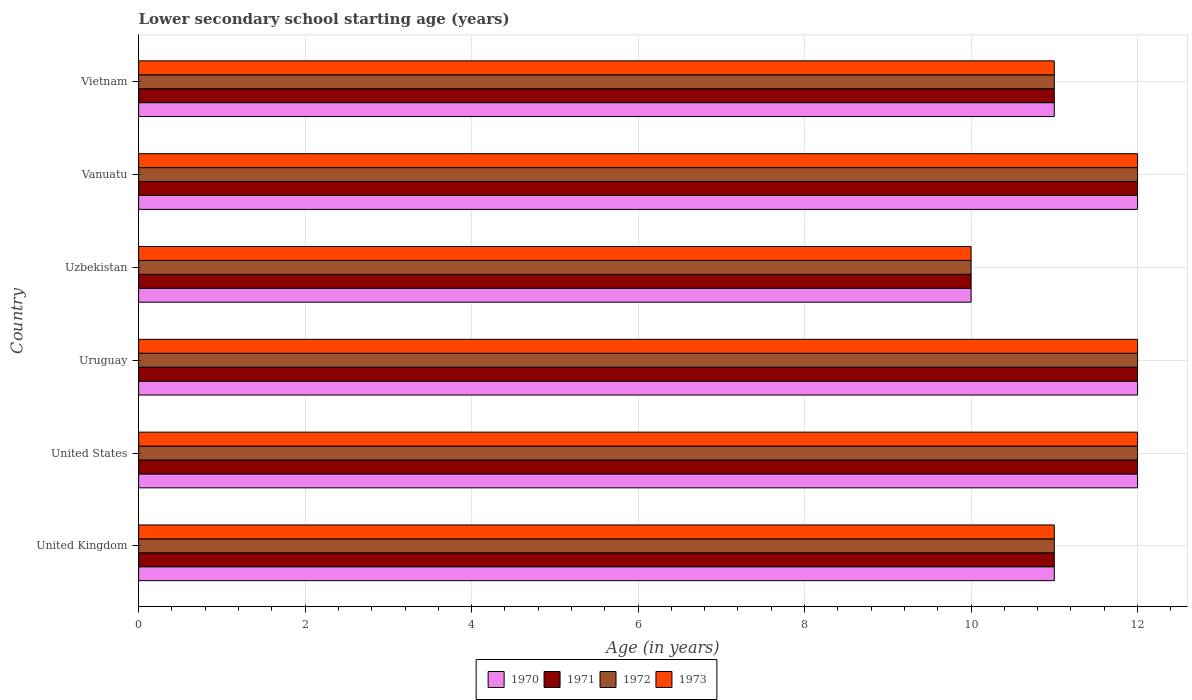How many different coloured bars are there?
Provide a succinct answer. 4. How many groups of bars are there?
Give a very brief answer. 6. Are the number of bars per tick equal to the number of legend labels?
Provide a succinct answer. Yes. Are the number of bars on each tick of the Y-axis equal?
Offer a very short reply. Yes. How many bars are there on the 2nd tick from the top?
Give a very brief answer. 4. What is the label of the 1st group of bars from the top?
Keep it short and to the point. Vietnam. In how many cases, is the number of bars for a given country not equal to the number of legend labels?
Ensure brevity in your answer.  0. Across all countries, what is the minimum lower secondary school starting age of children in 1970?
Offer a very short reply. 10. In which country was the lower secondary school starting age of children in 1971 minimum?
Ensure brevity in your answer.  Uzbekistan. What is the difference between the lower secondary school starting age of children in 1970 in United Kingdom and that in Vietnam?
Provide a short and direct response. 0. What is the average lower secondary school starting age of children in 1970 per country?
Ensure brevity in your answer.  11.33. What is the difference between the lower secondary school starting age of children in 1970 and lower secondary school starting age of children in 1971 in United States?
Keep it short and to the point. 0. What is the ratio of the lower secondary school starting age of children in 1972 in United Kingdom to that in Vanuatu?
Offer a terse response. 0.92. What is the difference between the highest and the second highest lower secondary school starting age of children in 1973?
Provide a short and direct response. 0. What is the difference between the highest and the lowest lower secondary school starting age of children in 1971?
Offer a very short reply. 2. In how many countries, is the lower secondary school starting age of children in 1972 greater than the average lower secondary school starting age of children in 1972 taken over all countries?
Offer a terse response. 3. Is the sum of the lower secondary school starting age of children in 1970 in United Kingdom and United States greater than the maximum lower secondary school starting age of children in 1972 across all countries?
Offer a very short reply. Yes. Is it the case that in every country, the sum of the lower secondary school starting age of children in 1971 and lower secondary school starting age of children in 1972 is greater than the sum of lower secondary school starting age of children in 1973 and lower secondary school starting age of children in 1970?
Your response must be concise. No. What does the 1st bar from the top in United States represents?
Ensure brevity in your answer.  1973. What does the 3rd bar from the bottom in Uruguay represents?
Provide a succinct answer. 1972. Are all the bars in the graph horizontal?
Your answer should be compact. Yes. How many countries are there in the graph?
Give a very brief answer. 6. What is the difference between two consecutive major ticks on the X-axis?
Offer a terse response. 2. Where does the legend appear in the graph?
Provide a short and direct response. Bottom center. What is the title of the graph?
Your answer should be very brief. Lower secondary school starting age (years). What is the label or title of the X-axis?
Offer a terse response. Age (in years). What is the Age (in years) of 1970 in United Kingdom?
Your answer should be compact. 11. What is the Age (in years) in 1971 in United Kingdom?
Ensure brevity in your answer.  11. What is the Age (in years) in 1970 in United States?
Provide a succinct answer. 12. What is the Age (in years) of 1972 in United States?
Provide a short and direct response. 12. What is the Age (in years) in 1970 in Uruguay?
Your answer should be compact. 12. What is the Age (in years) of 1971 in Uruguay?
Provide a short and direct response. 12. What is the Age (in years) of 1972 in Uruguay?
Your response must be concise. 12. What is the Age (in years) in 1970 in Uzbekistan?
Make the answer very short. 10. What is the Age (in years) in 1972 in Uzbekistan?
Your response must be concise. 10. What is the Age (in years) of 1970 in Vanuatu?
Provide a short and direct response. 12. What is the Age (in years) in 1972 in Vanuatu?
Ensure brevity in your answer.  12. What is the Age (in years) of 1973 in Vanuatu?
Keep it short and to the point. 12. What is the Age (in years) of 1972 in Vietnam?
Your response must be concise. 11. What is the Age (in years) of 1973 in Vietnam?
Ensure brevity in your answer.  11. Across all countries, what is the maximum Age (in years) of 1972?
Provide a short and direct response. 12. Across all countries, what is the minimum Age (in years) of 1971?
Your answer should be very brief. 10. Across all countries, what is the minimum Age (in years) of 1973?
Make the answer very short. 10. What is the difference between the Age (in years) of 1970 in United Kingdom and that in United States?
Your response must be concise. -1. What is the difference between the Age (in years) in 1973 in United Kingdom and that in United States?
Make the answer very short. -1. What is the difference between the Age (in years) of 1971 in United Kingdom and that in Uruguay?
Provide a short and direct response. -1. What is the difference between the Age (in years) of 1972 in United Kingdom and that in Uruguay?
Your answer should be compact. -1. What is the difference between the Age (in years) in 1973 in United Kingdom and that in Uruguay?
Provide a short and direct response. -1. What is the difference between the Age (in years) in 1971 in United Kingdom and that in Uzbekistan?
Provide a succinct answer. 1. What is the difference between the Age (in years) of 1970 in United Kingdom and that in Vanuatu?
Provide a short and direct response. -1. What is the difference between the Age (in years) in 1973 in United Kingdom and that in Vanuatu?
Provide a short and direct response. -1. What is the difference between the Age (in years) in 1970 in United Kingdom and that in Vietnam?
Provide a succinct answer. 0. What is the difference between the Age (in years) in 1972 in United Kingdom and that in Vietnam?
Ensure brevity in your answer.  0. What is the difference between the Age (in years) in 1973 in United Kingdom and that in Vietnam?
Provide a short and direct response. 0. What is the difference between the Age (in years) in 1973 in United States and that in Uruguay?
Your answer should be compact. 0. What is the difference between the Age (in years) of 1972 in United States and that in Uzbekistan?
Offer a very short reply. 2. What is the difference between the Age (in years) of 1973 in United States and that in Uzbekistan?
Ensure brevity in your answer.  2. What is the difference between the Age (in years) in 1970 in United States and that in Vanuatu?
Your answer should be very brief. 0. What is the difference between the Age (in years) of 1971 in United States and that in Vanuatu?
Offer a terse response. 0. What is the difference between the Age (in years) of 1973 in United States and that in Vanuatu?
Make the answer very short. 0. What is the difference between the Age (in years) of 1971 in United States and that in Vietnam?
Keep it short and to the point. 1. What is the difference between the Age (in years) of 1972 in United States and that in Vietnam?
Offer a very short reply. 1. What is the difference between the Age (in years) in 1971 in Uruguay and that in Uzbekistan?
Make the answer very short. 2. What is the difference between the Age (in years) in 1972 in Uruguay and that in Vanuatu?
Provide a short and direct response. 0. What is the difference between the Age (in years) of 1972 in Uruguay and that in Vietnam?
Provide a short and direct response. 1. What is the difference between the Age (in years) of 1973 in Uruguay and that in Vietnam?
Ensure brevity in your answer.  1. What is the difference between the Age (in years) of 1970 in Uzbekistan and that in Vanuatu?
Your answer should be very brief. -2. What is the difference between the Age (in years) in 1973 in Uzbekistan and that in Vanuatu?
Provide a succinct answer. -2. What is the difference between the Age (in years) in 1970 in Uzbekistan and that in Vietnam?
Give a very brief answer. -1. What is the difference between the Age (in years) in 1971 in Uzbekistan and that in Vietnam?
Ensure brevity in your answer.  -1. What is the difference between the Age (in years) of 1972 in Uzbekistan and that in Vietnam?
Provide a short and direct response. -1. What is the difference between the Age (in years) of 1973 in Uzbekistan and that in Vietnam?
Offer a very short reply. -1. What is the difference between the Age (in years) of 1971 in Vanuatu and that in Vietnam?
Make the answer very short. 1. What is the difference between the Age (in years) of 1973 in Vanuatu and that in Vietnam?
Make the answer very short. 1. What is the difference between the Age (in years) of 1970 in United Kingdom and the Age (in years) of 1971 in United States?
Provide a succinct answer. -1. What is the difference between the Age (in years) in 1971 in United Kingdom and the Age (in years) in 1972 in United States?
Keep it short and to the point. -1. What is the difference between the Age (in years) in 1971 in United Kingdom and the Age (in years) in 1973 in United States?
Give a very brief answer. -1. What is the difference between the Age (in years) in 1972 in United Kingdom and the Age (in years) in 1973 in United States?
Give a very brief answer. -1. What is the difference between the Age (in years) of 1970 in United Kingdom and the Age (in years) of 1972 in Uruguay?
Make the answer very short. -1. What is the difference between the Age (in years) in 1970 in United Kingdom and the Age (in years) in 1973 in Uruguay?
Ensure brevity in your answer.  -1. What is the difference between the Age (in years) in 1971 in United Kingdom and the Age (in years) in 1973 in Uruguay?
Make the answer very short. -1. What is the difference between the Age (in years) in 1970 in United Kingdom and the Age (in years) in 1972 in Vanuatu?
Offer a very short reply. -1. What is the difference between the Age (in years) of 1970 in United Kingdom and the Age (in years) of 1973 in Vanuatu?
Offer a terse response. -1. What is the difference between the Age (in years) of 1971 in United Kingdom and the Age (in years) of 1972 in Vanuatu?
Your answer should be very brief. -1. What is the difference between the Age (in years) of 1970 in United Kingdom and the Age (in years) of 1973 in Vietnam?
Make the answer very short. 0. What is the difference between the Age (in years) in 1971 in United Kingdom and the Age (in years) in 1972 in Vietnam?
Give a very brief answer. 0. What is the difference between the Age (in years) in 1972 in United Kingdom and the Age (in years) in 1973 in Vietnam?
Ensure brevity in your answer.  0. What is the difference between the Age (in years) of 1971 in United States and the Age (in years) of 1973 in Uruguay?
Your answer should be very brief. 0. What is the difference between the Age (in years) in 1972 in United States and the Age (in years) in 1973 in Uruguay?
Offer a very short reply. 0. What is the difference between the Age (in years) in 1970 in United States and the Age (in years) in 1971 in Uzbekistan?
Your answer should be very brief. 2. What is the difference between the Age (in years) of 1970 in United States and the Age (in years) of 1972 in Uzbekistan?
Keep it short and to the point. 2. What is the difference between the Age (in years) in 1971 in United States and the Age (in years) in 1973 in Uzbekistan?
Your answer should be compact. 2. What is the difference between the Age (in years) in 1972 in United States and the Age (in years) in 1973 in Uzbekistan?
Your answer should be very brief. 2. What is the difference between the Age (in years) of 1970 in United States and the Age (in years) of 1971 in Vanuatu?
Make the answer very short. 0. What is the difference between the Age (in years) in 1970 in United States and the Age (in years) in 1973 in Vanuatu?
Your answer should be compact. 0. What is the difference between the Age (in years) in 1971 in United States and the Age (in years) in 1972 in Vanuatu?
Make the answer very short. 0. What is the difference between the Age (in years) in 1972 in United States and the Age (in years) in 1973 in Vanuatu?
Your response must be concise. 0. What is the difference between the Age (in years) of 1972 in United States and the Age (in years) of 1973 in Vietnam?
Provide a short and direct response. 1. What is the difference between the Age (in years) in 1971 in Uruguay and the Age (in years) in 1972 in Uzbekistan?
Give a very brief answer. 2. What is the difference between the Age (in years) of 1970 in Uruguay and the Age (in years) of 1972 in Vanuatu?
Ensure brevity in your answer.  0. What is the difference between the Age (in years) in 1970 in Uruguay and the Age (in years) in 1973 in Vanuatu?
Provide a succinct answer. 0. What is the difference between the Age (in years) of 1970 in Uruguay and the Age (in years) of 1971 in Vietnam?
Your answer should be very brief. 1. What is the difference between the Age (in years) of 1970 in Uruguay and the Age (in years) of 1973 in Vietnam?
Make the answer very short. 1. What is the difference between the Age (in years) in 1971 in Uruguay and the Age (in years) in 1972 in Vietnam?
Offer a very short reply. 1. What is the difference between the Age (in years) of 1972 in Uruguay and the Age (in years) of 1973 in Vietnam?
Your answer should be very brief. 1. What is the difference between the Age (in years) of 1970 in Uzbekistan and the Age (in years) of 1971 in Vanuatu?
Offer a very short reply. -2. What is the difference between the Age (in years) of 1970 in Uzbekistan and the Age (in years) of 1973 in Vanuatu?
Offer a very short reply. -2. What is the difference between the Age (in years) in 1971 in Uzbekistan and the Age (in years) in 1973 in Vanuatu?
Make the answer very short. -2. What is the difference between the Age (in years) of 1972 in Uzbekistan and the Age (in years) of 1973 in Vanuatu?
Provide a short and direct response. -2. What is the difference between the Age (in years) in 1970 in Uzbekistan and the Age (in years) in 1971 in Vietnam?
Provide a short and direct response. -1. What is the difference between the Age (in years) of 1970 in Uzbekistan and the Age (in years) of 1972 in Vietnam?
Ensure brevity in your answer.  -1. What is the difference between the Age (in years) of 1970 in Uzbekistan and the Age (in years) of 1973 in Vietnam?
Ensure brevity in your answer.  -1. What is the difference between the Age (in years) of 1971 in Uzbekistan and the Age (in years) of 1973 in Vietnam?
Offer a very short reply. -1. What is the difference between the Age (in years) of 1970 in Vanuatu and the Age (in years) of 1973 in Vietnam?
Ensure brevity in your answer.  1. What is the average Age (in years) of 1970 per country?
Provide a short and direct response. 11.33. What is the average Age (in years) in 1971 per country?
Give a very brief answer. 11.33. What is the average Age (in years) of 1972 per country?
Provide a succinct answer. 11.33. What is the average Age (in years) in 1973 per country?
Your answer should be compact. 11.33. What is the difference between the Age (in years) of 1970 and Age (in years) of 1971 in United States?
Your response must be concise. 0. What is the difference between the Age (in years) in 1970 and Age (in years) in 1972 in United States?
Ensure brevity in your answer.  0. What is the difference between the Age (in years) in 1971 and Age (in years) in 1973 in United States?
Ensure brevity in your answer.  0. What is the difference between the Age (in years) in 1972 and Age (in years) in 1973 in United States?
Your response must be concise. 0. What is the difference between the Age (in years) in 1970 and Age (in years) in 1971 in Uruguay?
Your response must be concise. 0. What is the difference between the Age (in years) of 1971 and Age (in years) of 1972 in Uruguay?
Your answer should be very brief. 0. What is the difference between the Age (in years) of 1971 and Age (in years) of 1973 in Uruguay?
Offer a terse response. 0. What is the difference between the Age (in years) in 1972 and Age (in years) in 1973 in Uruguay?
Keep it short and to the point. 0. What is the difference between the Age (in years) of 1970 and Age (in years) of 1971 in Uzbekistan?
Offer a terse response. 0. What is the difference between the Age (in years) of 1970 and Age (in years) of 1973 in Uzbekistan?
Offer a very short reply. 0. What is the difference between the Age (in years) in 1971 and Age (in years) in 1972 in Uzbekistan?
Your answer should be compact. 0. What is the difference between the Age (in years) of 1971 and Age (in years) of 1973 in Uzbekistan?
Give a very brief answer. 0. What is the difference between the Age (in years) in 1972 and Age (in years) in 1973 in Uzbekistan?
Keep it short and to the point. 0. What is the difference between the Age (in years) in 1970 and Age (in years) in 1971 in Vanuatu?
Keep it short and to the point. 0. What is the difference between the Age (in years) of 1970 and Age (in years) of 1972 in Vanuatu?
Ensure brevity in your answer.  0. What is the difference between the Age (in years) in 1970 and Age (in years) in 1971 in Vietnam?
Give a very brief answer. 0. What is the difference between the Age (in years) in 1970 and Age (in years) in 1972 in Vietnam?
Keep it short and to the point. 0. What is the difference between the Age (in years) of 1970 and Age (in years) of 1973 in Vietnam?
Offer a terse response. 0. What is the difference between the Age (in years) in 1971 and Age (in years) in 1972 in Vietnam?
Your answer should be compact. 0. What is the ratio of the Age (in years) in 1970 in United Kingdom to that in United States?
Make the answer very short. 0.92. What is the ratio of the Age (in years) of 1971 in United Kingdom to that in United States?
Give a very brief answer. 0.92. What is the ratio of the Age (in years) in 1972 in United Kingdom to that in United States?
Ensure brevity in your answer.  0.92. What is the ratio of the Age (in years) of 1970 in United Kingdom to that in Uruguay?
Give a very brief answer. 0.92. What is the ratio of the Age (in years) in 1972 in United Kingdom to that in Uruguay?
Make the answer very short. 0.92. What is the ratio of the Age (in years) in 1972 in United Kingdom to that in Uzbekistan?
Offer a terse response. 1.1. What is the ratio of the Age (in years) in 1973 in United Kingdom to that in Uzbekistan?
Give a very brief answer. 1.1. What is the ratio of the Age (in years) of 1970 in United Kingdom to that in Vanuatu?
Provide a succinct answer. 0.92. What is the ratio of the Age (in years) of 1971 in United Kingdom to that in Vanuatu?
Make the answer very short. 0.92. What is the ratio of the Age (in years) in 1972 in United Kingdom to that in Vanuatu?
Your response must be concise. 0.92. What is the ratio of the Age (in years) of 1970 in United Kingdom to that in Vietnam?
Give a very brief answer. 1. What is the ratio of the Age (in years) of 1972 in United Kingdom to that in Vietnam?
Ensure brevity in your answer.  1. What is the ratio of the Age (in years) in 1973 in United Kingdom to that in Vietnam?
Your response must be concise. 1. What is the ratio of the Age (in years) of 1970 in United States to that in Uruguay?
Make the answer very short. 1. What is the ratio of the Age (in years) in 1972 in United States to that in Uruguay?
Your answer should be very brief. 1. What is the ratio of the Age (in years) of 1970 in United States to that in Uzbekistan?
Provide a short and direct response. 1.2. What is the ratio of the Age (in years) in 1973 in United States to that in Uzbekistan?
Provide a short and direct response. 1.2. What is the ratio of the Age (in years) of 1970 in United States to that in Vanuatu?
Keep it short and to the point. 1. What is the ratio of the Age (in years) in 1971 in United States to that in Vanuatu?
Your answer should be compact. 1. What is the ratio of the Age (in years) of 1973 in United States to that in Vanuatu?
Ensure brevity in your answer.  1. What is the ratio of the Age (in years) of 1971 in United States to that in Vietnam?
Ensure brevity in your answer.  1.09. What is the ratio of the Age (in years) of 1973 in United States to that in Vietnam?
Your answer should be compact. 1.09. What is the ratio of the Age (in years) of 1970 in Uruguay to that in Uzbekistan?
Your response must be concise. 1.2. What is the ratio of the Age (in years) in 1973 in Uruguay to that in Uzbekistan?
Provide a succinct answer. 1.2. What is the ratio of the Age (in years) in 1970 in Uruguay to that in Vanuatu?
Make the answer very short. 1. What is the ratio of the Age (in years) in 1971 in Uruguay to that in Vanuatu?
Provide a succinct answer. 1. What is the ratio of the Age (in years) of 1972 in Uruguay to that in Vanuatu?
Give a very brief answer. 1. What is the ratio of the Age (in years) in 1973 in Uruguay to that in Vanuatu?
Make the answer very short. 1. What is the ratio of the Age (in years) in 1970 in Uruguay to that in Vietnam?
Keep it short and to the point. 1.09. What is the ratio of the Age (in years) in 1972 in Uruguay to that in Vietnam?
Provide a succinct answer. 1.09. What is the ratio of the Age (in years) of 1973 in Uruguay to that in Vietnam?
Ensure brevity in your answer.  1.09. What is the ratio of the Age (in years) of 1972 in Uzbekistan to that in Vanuatu?
Provide a succinct answer. 0.83. What is the ratio of the Age (in years) in 1971 in Uzbekistan to that in Vietnam?
Offer a terse response. 0.91. What is the ratio of the Age (in years) of 1973 in Uzbekistan to that in Vietnam?
Offer a terse response. 0.91. What is the ratio of the Age (in years) of 1970 in Vanuatu to that in Vietnam?
Your response must be concise. 1.09. What is the ratio of the Age (in years) of 1971 in Vanuatu to that in Vietnam?
Ensure brevity in your answer.  1.09. What is the ratio of the Age (in years) in 1972 in Vanuatu to that in Vietnam?
Provide a succinct answer. 1.09. What is the ratio of the Age (in years) in 1973 in Vanuatu to that in Vietnam?
Make the answer very short. 1.09. What is the difference between the highest and the second highest Age (in years) in 1973?
Provide a succinct answer. 0. What is the difference between the highest and the lowest Age (in years) in 1970?
Your response must be concise. 2. What is the difference between the highest and the lowest Age (in years) of 1971?
Offer a very short reply. 2. 